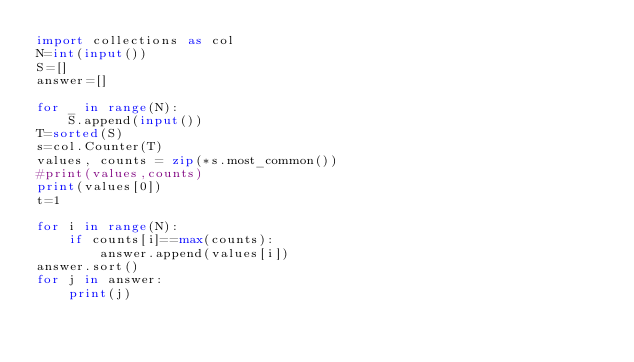Convert code to text. <code><loc_0><loc_0><loc_500><loc_500><_Python_>import collections as col
N=int(input())
S=[]
answer=[]

for _ in range(N):
    S.append(input())
T=sorted(S)
s=col.Counter(T)
values, counts = zip(*s.most_common())
#print(values,counts)
print(values[0])
t=1

for i in range(N):
    if counts[i]==max(counts):
        answer.append(values[i])
answer.sort()
for j in answer:
    print(j)
 </code> 